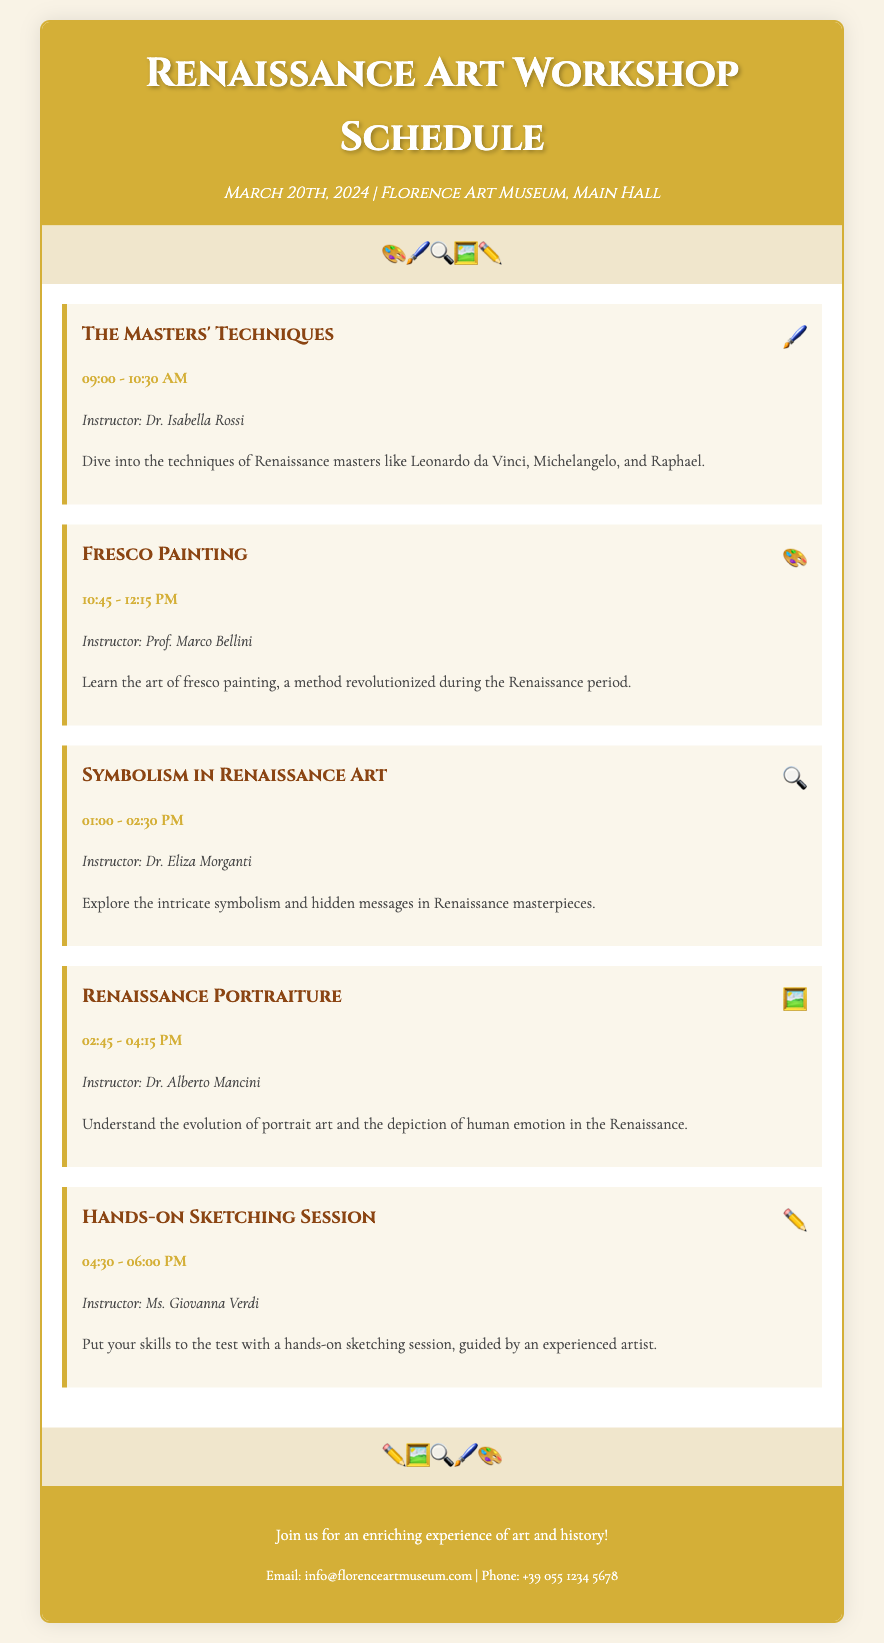What is the date of the workshop? The date of the workshop is specified in the header of the document.
Answer: March 20th, 2024 Who is the instructor for the Fresco Painting session? The instructor for the Fresco Painting session is mentioned under the respective session details.
Answer: Prof. Marco Bellini What time does the Hands-on Sketching Session start? The start time for the Hands-on Sketching Session is listed in the session details.
Answer: 04:30 PM How many sessions are there in total? The total number of sessions is counted from the list provided in the document.
Answer: Five What is the title of the session that discusses symbolism? The title is found in the header of the specified session.
Answer: Symbolism in Renaissance Art Who is the last instructor mentioned in the schedule? The last instructor is mentioned at the end of the list of sessions.
Answer: Ms. Giovanna Verdi What is the main location of the workshop? The main location of the workshop is stated in the header under the date.
Answer: Florence Art Museum, Main Hall Which session starts at 1:00 PM? The session starting at 1:00 PM is highlighted in the session details.
Answer: Symbolism in Renaissance Art What icon represents the Masters' Techniques session? The icon for the Masters' Techniques session is provided next to the session title.
Answer: 🖌️ 